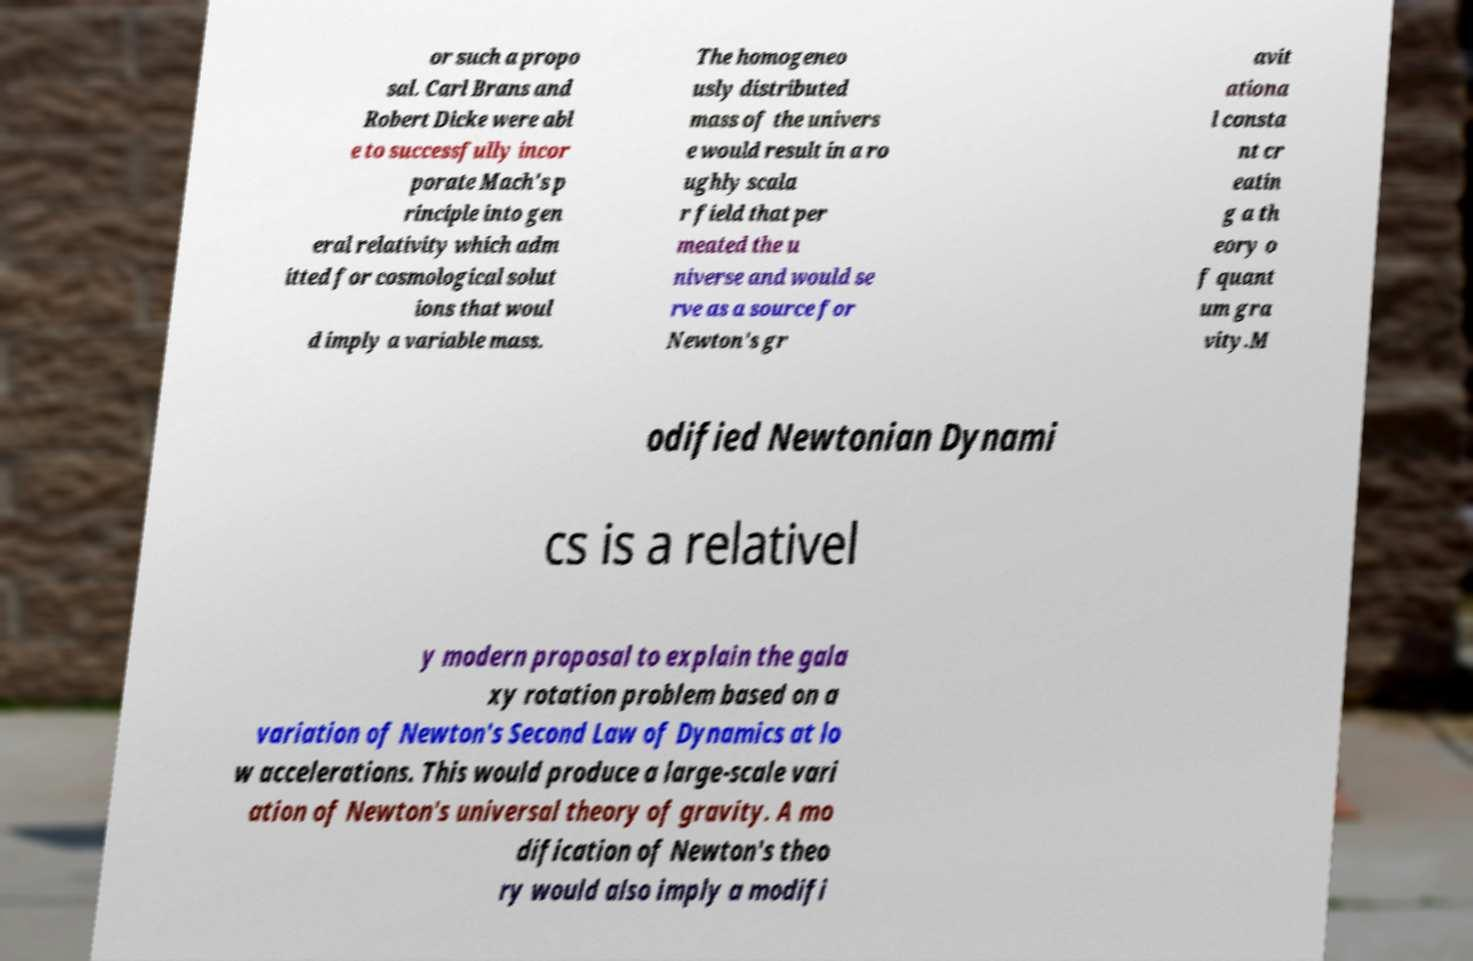Can you read and provide the text displayed in the image?This photo seems to have some interesting text. Can you extract and type it out for me? or such a propo sal. Carl Brans and Robert Dicke were abl e to successfully incor porate Mach's p rinciple into gen eral relativity which adm itted for cosmological solut ions that woul d imply a variable mass. The homogeneo usly distributed mass of the univers e would result in a ro ughly scala r field that per meated the u niverse and would se rve as a source for Newton's gr avit ationa l consta nt cr eatin g a th eory o f quant um gra vity.M odified Newtonian Dynami cs is a relativel y modern proposal to explain the gala xy rotation problem based on a variation of Newton's Second Law of Dynamics at lo w accelerations. This would produce a large-scale vari ation of Newton's universal theory of gravity. A mo dification of Newton's theo ry would also imply a modifi 